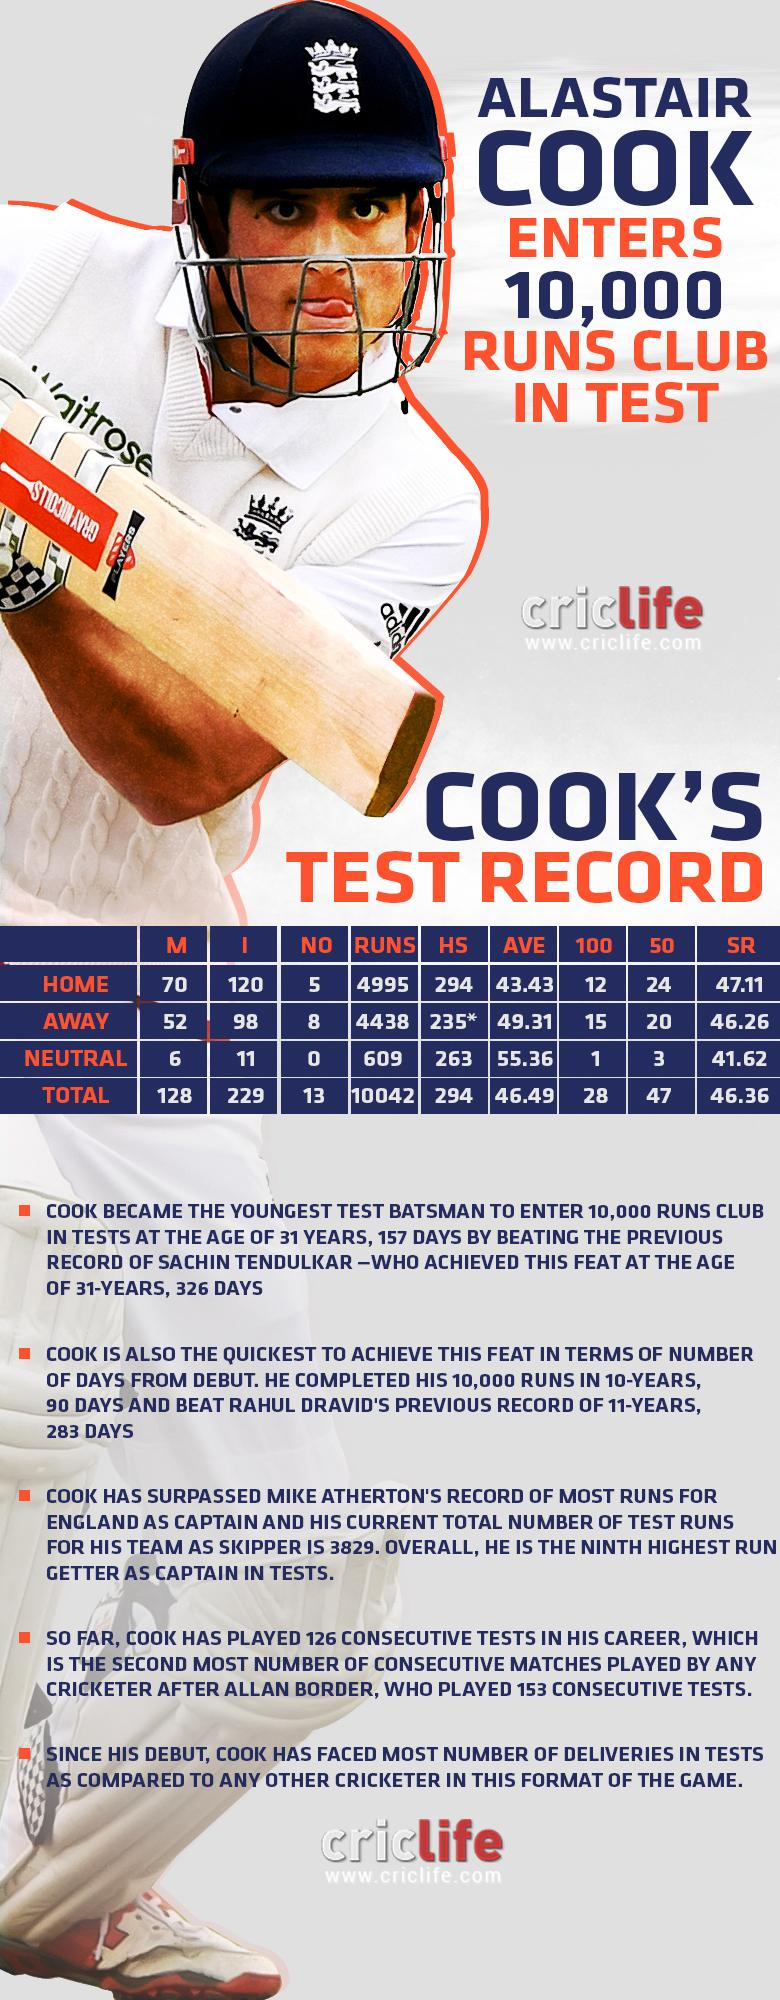Highlight a few significant elements in this photo. Alastair Cook has scored the highest test score of 294 in home matches. In Alastair Cook's home test matches, a total of 24 half-centuries were scored. England's Alastair Cook played for the country. Alastair Cook has scored a total of 4438 runs in both home and away test matches. Alastair Cook scored a total of 15 hundreds in both his home and away test matches. 